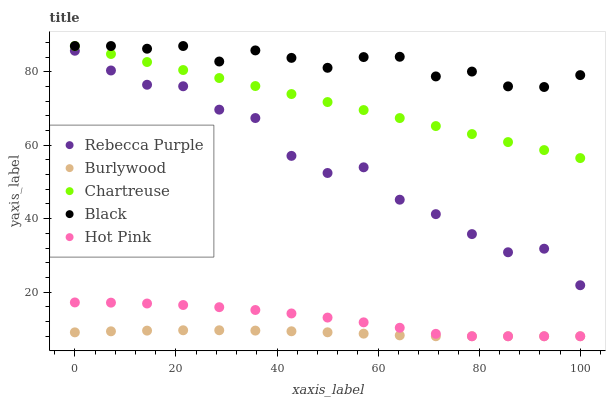Does Burlywood have the minimum area under the curve?
Answer yes or no. Yes. Does Black have the maximum area under the curve?
Answer yes or no. Yes. Does Chartreuse have the minimum area under the curve?
Answer yes or no. No. Does Chartreuse have the maximum area under the curve?
Answer yes or no. No. Is Chartreuse the smoothest?
Answer yes or no. Yes. Is Rebecca Purple the roughest?
Answer yes or no. Yes. Is Hot Pink the smoothest?
Answer yes or no. No. Is Hot Pink the roughest?
Answer yes or no. No. Does Burlywood have the lowest value?
Answer yes or no. Yes. Does Chartreuse have the lowest value?
Answer yes or no. No. Does Black have the highest value?
Answer yes or no. Yes. Does Hot Pink have the highest value?
Answer yes or no. No. Is Rebecca Purple less than Chartreuse?
Answer yes or no. Yes. Is Black greater than Burlywood?
Answer yes or no. Yes. Does Hot Pink intersect Burlywood?
Answer yes or no. Yes. Is Hot Pink less than Burlywood?
Answer yes or no. No. Is Hot Pink greater than Burlywood?
Answer yes or no. No. Does Rebecca Purple intersect Chartreuse?
Answer yes or no. No. 